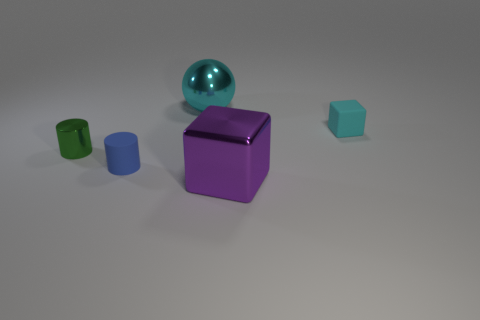Do the tiny rubber cube and the large shiny sphere have the same color?
Ensure brevity in your answer.  Yes. There is a metal thing in front of the small rubber thing that is to the left of the large purple metallic thing that is in front of the tiny blue matte thing; what size is it?
Your response must be concise. Large. What number of other objects are the same size as the metal block?
Your response must be concise. 1. What number of cylinders are the same material as the tiny cyan block?
Your answer should be very brief. 1. The rubber thing on the right side of the matte cylinder has what shape?
Ensure brevity in your answer.  Cube. Is the blue cylinder made of the same material as the block that is on the left side of the rubber block?
Your answer should be compact. No. Are there any large red metallic cubes?
Keep it short and to the point. No. Are there any big cyan objects that are in front of the tiny matte object that is on the right side of the matte thing to the left of the cyan metallic ball?
Your answer should be compact. No. What number of tiny objects are yellow metallic things or rubber cubes?
Give a very brief answer. 1. What color is the matte cube that is the same size as the green metallic object?
Offer a terse response. Cyan. 